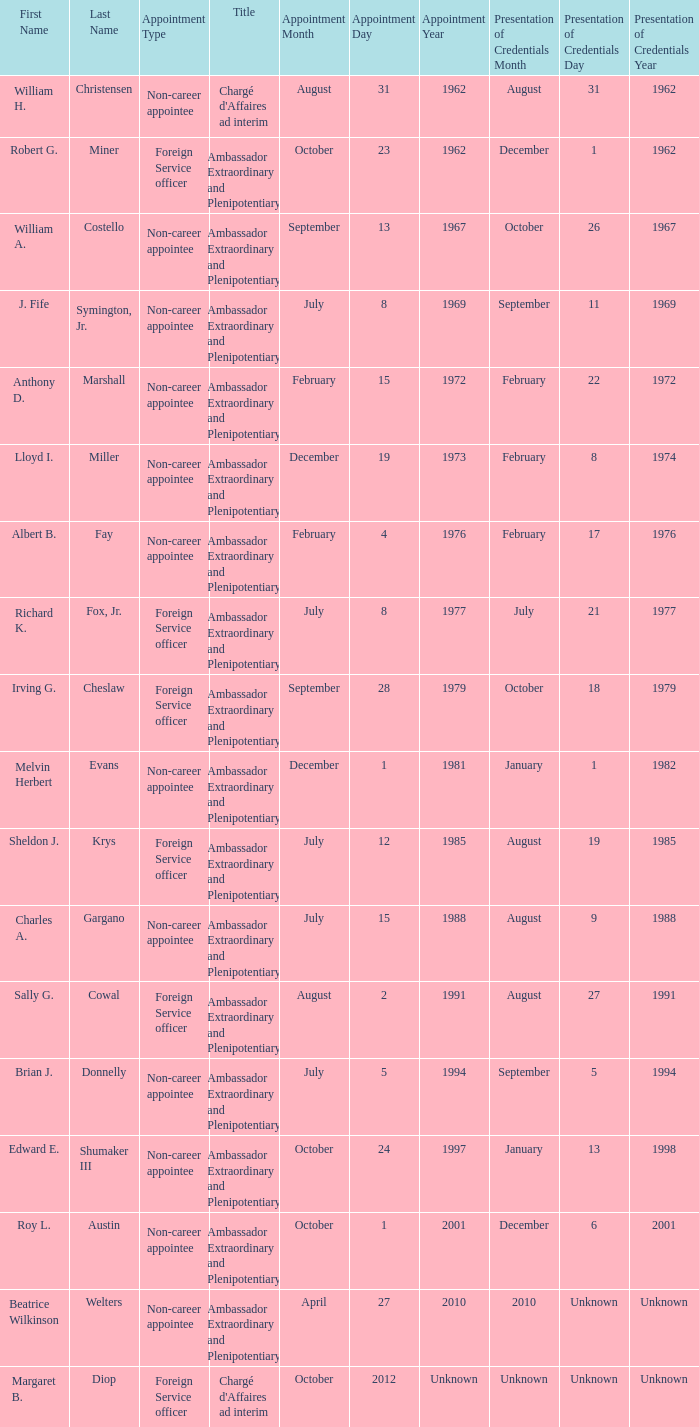Who presented their credentials at an unknown date? Margaret B. Diop. 